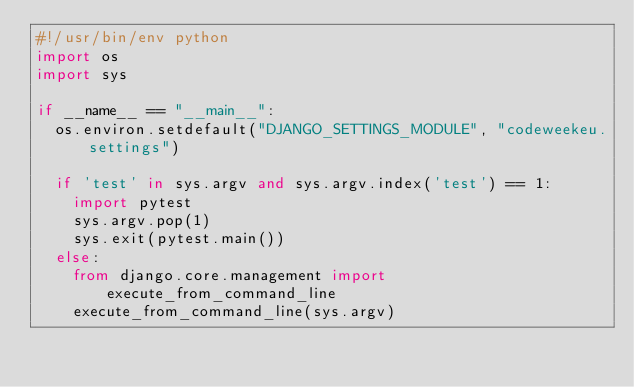<code> <loc_0><loc_0><loc_500><loc_500><_Python_>#!/usr/bin/env python
import os
import sys

if __name__ == "__main__":
	os.environ.setdefault("DJANGO_SETTINGS_MODULE", "codeweekeu.settings")

	if 'test' in sys.argv and sys.argv.index('test') == 1:
		import pytest
		sys.argv.pop(1)
		sys.exit(pytest.main())
	else:
		from django.core.management import execute_from_command_line
		execute_from_command_line(sys.argv)
</code> 